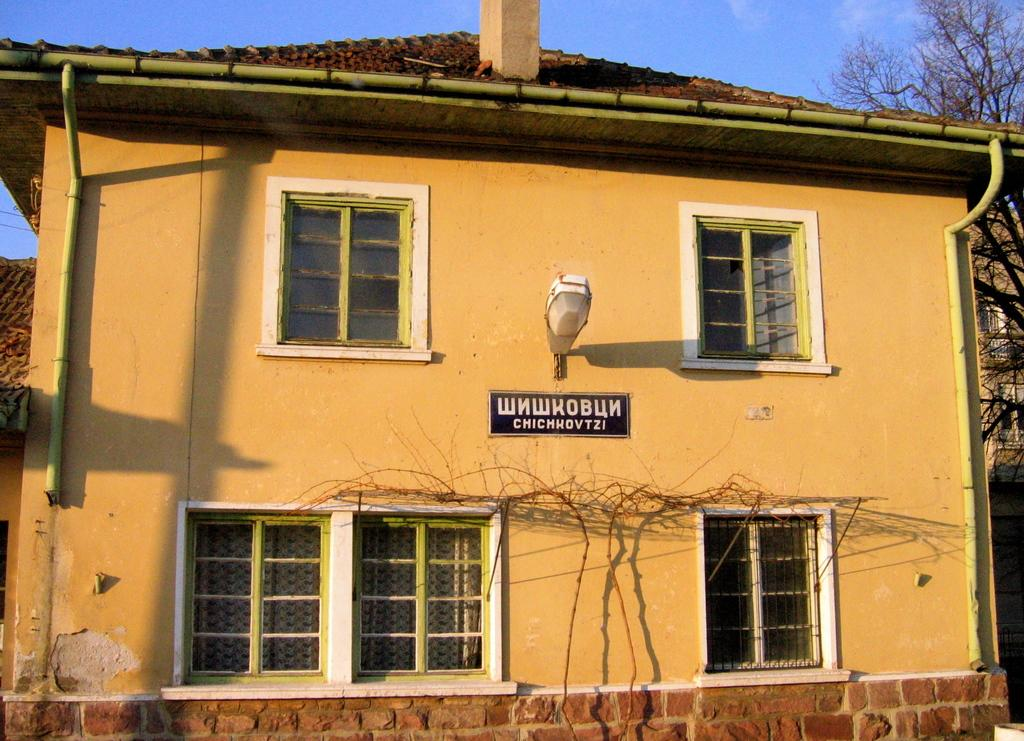<image>
Render a clear and concise summary of the photo. yellow two story building with sign showing wnwkobun chichkovtzi 